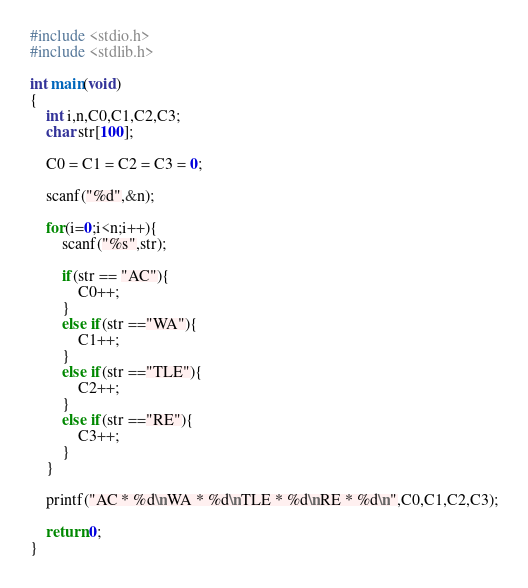<code> <loc_0><loc_0><loc_500><loc_500><_C_>#include <stdio.h>
#include <stdlib.h>

int main(void)
{
	int i,n,C0,C1,C2,C3;
	char str[100];

	C0 = C1 = C2 = C3 = 0;
	
	scanf("%d",&n);

	for(i=0;i<n;i++){
		scanf("%s",str);

		if(str == "AC"){
			C0++;
		}
		else if(str =="WA"){
			C1++;
		}
		else if(str =="TLE"){
			C2++;
		}
		else if(str =="RE"){
			C3++;
		}
	}

	printf("AC * %d\nWA * %d\nTLE * %d\nRE * %d\n",C0,C1,C2,C3);

	return 0;
}
</code> 